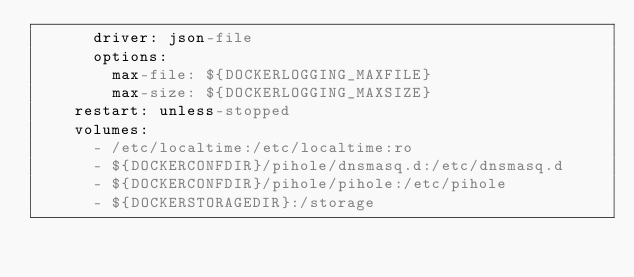Convert code to text. <code><loc_0><loc_0><loc_500><loc_500><_YAML_>      driver: json-file
      options:
        max-file: ${DOCKERLOGGING_MAXFILE}
        max-size: ${DOCKERLOGGING_MAXSIZE}
    restart: unless-stopped
    volumes:
      - /etc/localtime:/etc/localtime:ro
      - ${DOCKERCONFDIR}/pihole/dnsmasq.d:/etc/dnsmasq.d
      - ${DOCKERCONFDIR}/pihole/pihole:/etc/pihole
      - ${DOCKERSTORAGEDIR}:/storage
</code> 